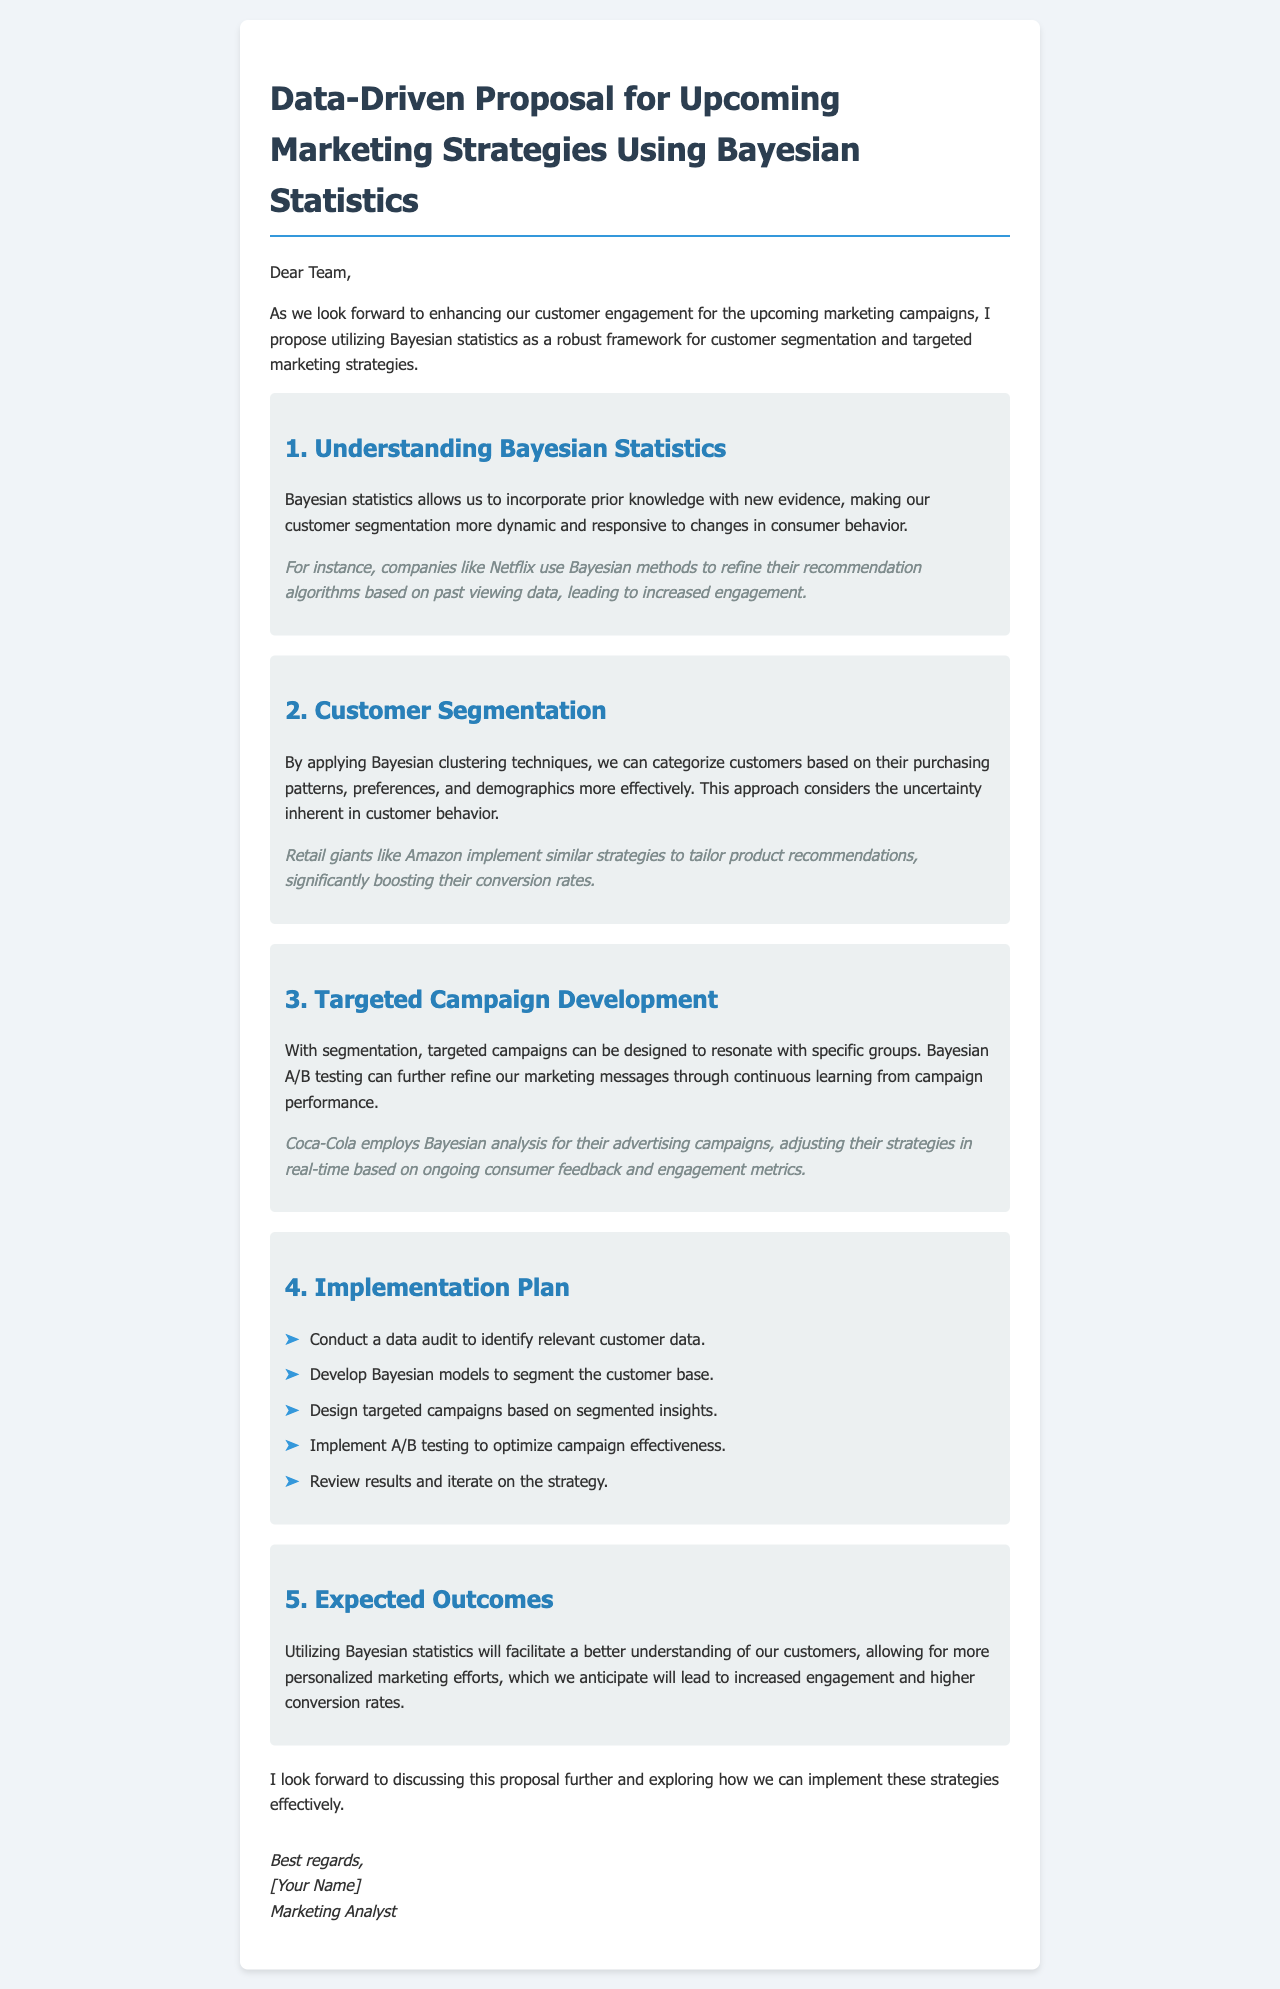What is the title of the proposal? The title is the overarching subject of the document outlined in the <h1> tag.
Answer: Data-Driven Proposal for Upcoming Marketing Strategies Using Bayesian Statistics Who uses Bayesian methods for recommendation algorithms? The reference in the first example highlights a well-known company utilizing Bayesian statistics.
Answer: Netflix What is one purpose of Bayesian clustering techniques mentioned? This describes the role of Bayesian clustering in customer analysis and segmentation.
Answer: Categorize customers Which company utilizes Bayesian analysis for advertising campaigns? The mention in the document provides an example of a specific company's application of Bayesian analysis.
Answer: Coca-Cola What is the expected outcome of using Bayesian statistics? The outcome highlights the anticipated benefit derived from the proposed statistical approach.
Answer: Increased engagement and higher conversion rates What is the first step in the implementation plan? The implementation plan outlines the sequence of steps; the first step is crucial to set up the project.
Answer: Conduct a data audit What can Bayesian A/B testing help refine? This phrase addresses the specific aspect of marketing messages that Bayesian A/B testing influences.
Answer: Marketing messages Which company boosts conversion rates by tailoring product recommendations? This refers to a known retail giant's strategy using Bayesian methods for customer targeting.
Answer: Amazon 